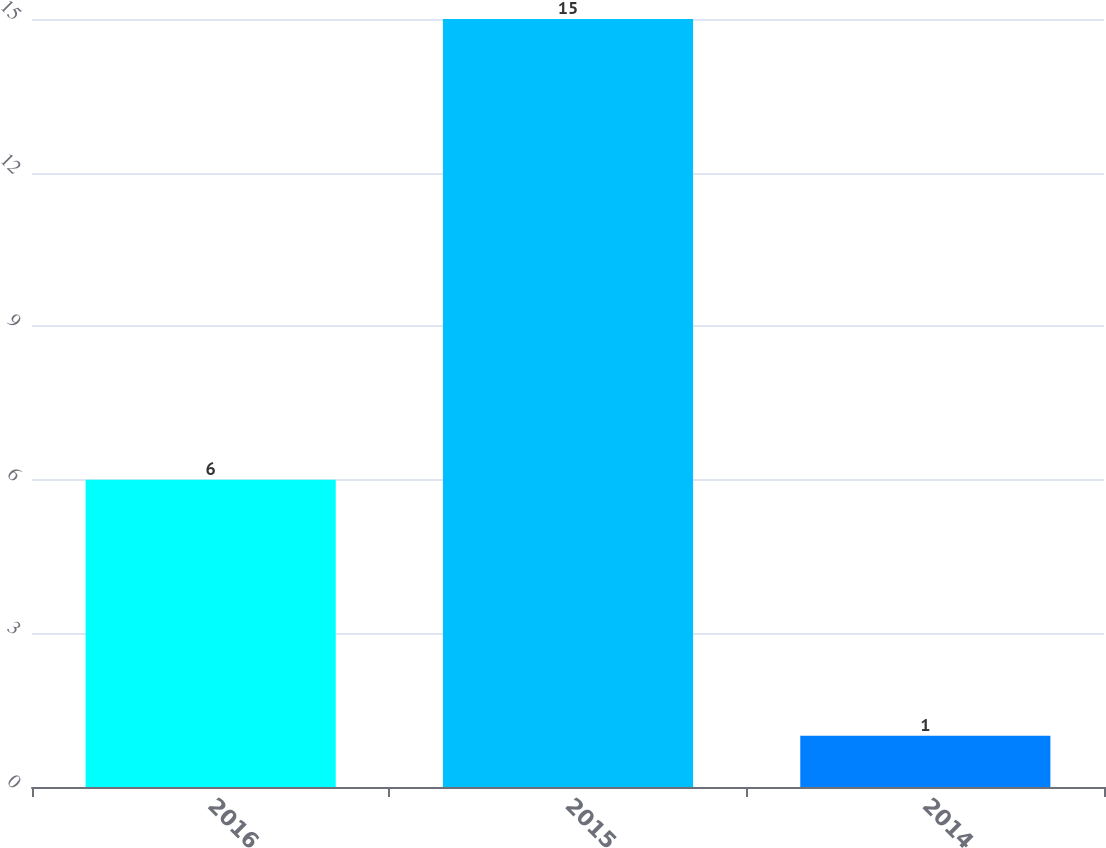<chart> <loc_0><loc_0><loc_500><loc_500><bar_chart><fcel>2016<fcel>2015<fcel>2014<nl><fcel>6<fcel>15<fcel>1<nl></chart> 